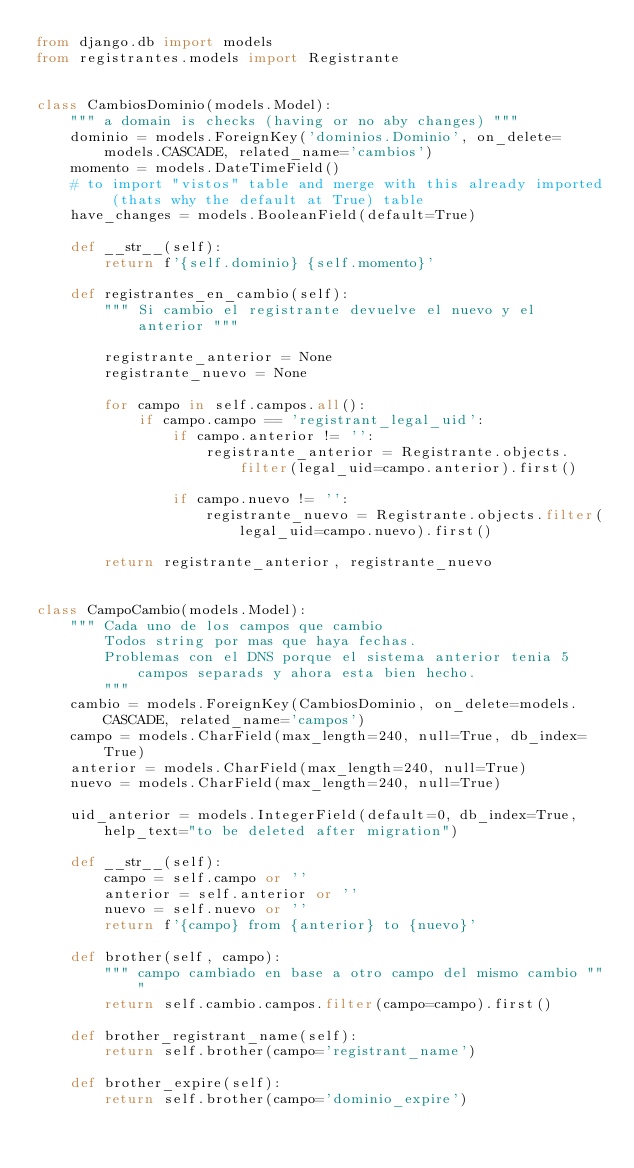Convert code to text. <code><loc_0><loc_0><loc_500><loc_500><_Python_>from django.db import models
from registrantes.models import Registrante


class CambiosDominio(models.Model):
    """ a domain is checks (having or no aby changes) """
    dominio = models.ForeignKey('dominios.Dominio', on_delete=models.CASCADE, related_name='cambios')
    momento = models.DateTimeField()
    # to import "vistos" table and merge with this already imported (thats why the default at True) table
    have_changes = models.BooleanField(default=True)

    def __str__(self):
        return f'{self.dominio} {self.momento}'

    def registrantes_en_cambio(self):
        """ Si cambio el registrante devuelve el nuevo y el anterior """

        registrante_anterior = None
        registrante_nuevo = None

        for campo in self.campos.all():
            if campo.campo == 'registrant_legal_uid':
                if campo.anterior != '':
                    registrante_anterior = Registrante.objects.filter(legal_uid=campo.anterior).first()

                if campo.nuevo != '':
                    registrante_nuevo = Registrante.objects.filter(legal_uid=campo.nuevo).first()

        return registrante_anterior, registrante_nuevo


class CampoCambio(models.Model):
    """ Cada uno de los campos que cambio 
        Todos string por mas que haya fechas. 
        Problemas con el DNS porque el sistema anterior tenia 5 
            campos separads y ahora esta bien hecho.
        """
    cambio = models.ForeignKey(CambiosDominio, on_delete=models.CASCADE, related_name='campos')
    campo = models.CharField(max_length=240, null=True, db_index=True)
    anterior = models.CharField(max_length=240, null=True)
    nuevo = models.CharField(max_length=240, null=True)

    uid_anterior = models.IntegerField(default=0, db_index=True, help_text="to be deleted after migration")

    def __str__(self):
        campo = self.campo or ''
        anterior = self.anterior or ''
        nuevo = self.nuevo or ''
        return f'{campo} from {anterior} to {nuevo}'

    def brother(self, campo):
        """ campo cambiado en base a otro campo del mismo cambio """
        return self.cambio.campos.filter(campo=campo).first()

    def brother_registrant_name(self):
        return self.brother(campo='registrant_name')

    def brother_expire(self):
        return self.brother(campo='dominio_expire')</code> 